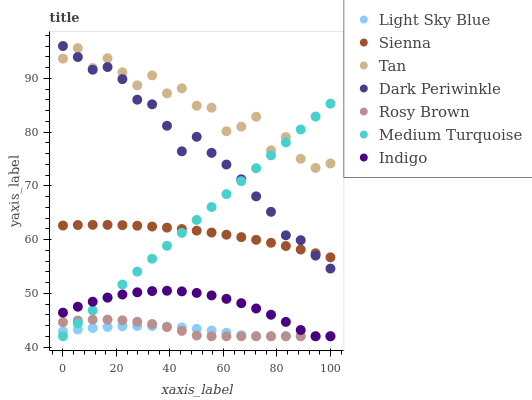Does Light Sky Blue have the minimum area under the curve?
Answer yes or no. Yes. Does Tan have the maximum area under the curve?
Answer yes or no. Yes. Does Rosy Brown have the minimum area under the curve?
Answer yes or no. No. Does Rosy Brown have the maximum area under the curve?
Answer yes or no. No. Is Medium Turquoise the smoothest?
Answer yes or no. Yes. Is Tan the roughest?
Answer yes or no. Yes. Is Rosy Brown the smoothest?
Answer yes or no. No. Is Rosy Brown the roughest?
Answer yes or no. No. Does Indigo have the lowest value?
Answer yes or no. Yes. Does Sienna have the lowest value?
Answer yes or no. No. Does Dark Periwinkle have the highest value?
Answer yes or no. Yes. Does Rosy Brown have the highest value?
Answer yes or no. No. Is Light Sky Blue less than Tan?
Answer yes or no. Yes. Is Dark Periwinkle greater than Light Sky Blue?
Answer yes or no. Yes. Does Medium Turquoise intersect Sienna?
Answer yes or no. Yes. Is Medium Turquoise less than Sienna?
Answer yes or no. No. Is Medium Turquoise greater than Sienna?
Answer yes or no. No. Does Light Sky Blue intersect Tan?
Answer yes or no. No. 